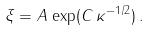Convert formula to latex. <formula><loc_0><loc_0><loc_500><loc_500>\xi = A \, \exp ( C \, \kappa ^ { - 1 / 2 } ) \, .</formula> 